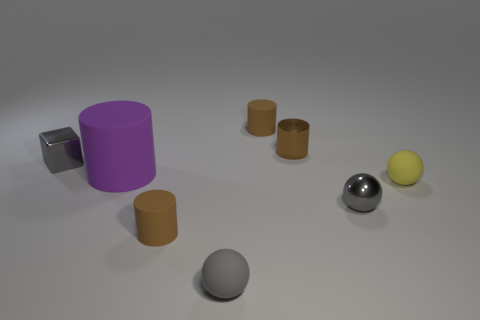How many large purple matte things are to the right of the brown metal thing?
Provide a short and direct response. 0. Are there fewer large things that are behind the tiny cube than small yellow balls to the left of the yellow sphere?
Provide a succinct answer. No. There is a metallic thing that is to the left of the small brown matte thing that is in front of the tiny matte cylinder behind the small brown metal thing; what is its shape?
Your answer should be very brief. Cube. There is a metallic object that is both behind the purple cylinder and on the right side of the gray metallic cube; what shape is it?
Offer a terse response. Cylinder. Is there a tiny cylinder made of the same material as the big object?
Your answer should be compact. Yes. There is a shiny thing that is the same color as the shiny block; what is its size?
Provide a succinct answer. Small. There is a big cylinder to the right of the gray metal cube; what color is it?
Your answer should be compact. Purple. Do the tiny gray rubber thing and the gray thing behind the large thing have the same shape?
Give a very brief answer. No. Is there a matte sphere of the same color as the shiny cube?
Ensure brevity in your answer.  Yes. What is the size of the other yellow object that is the same material as the big object?
Your answer should be compact. Small. 